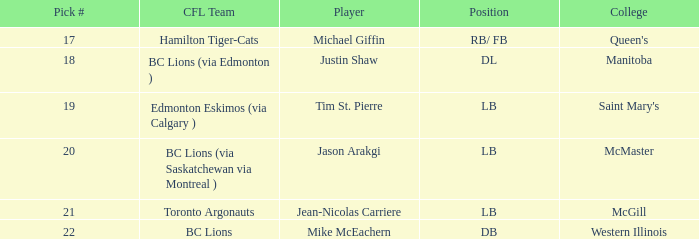For which college does jean-nicolas carriere participate in sports? McGill. Help me parse the entirety of this table. {'header': ['Pick #', 'CFL Team', 'Player', 'Position', 'College'], 'rows': [['17', 'Hamilton Tiger-Cats', 'Michael Giffin', 'RB/ FB', "Queen's"], ['18', 'BC Lions (via Edmonton )', 'Justin Shaw', 'DL', 'Manitoba'], ['19', 'Edmonton Eskimos (via Calgary )', 'Tim St. Pierre', 'LB', "Saint Mary's"], ['20', 'BC Lions (via Saskatchewan via Montreal )', 'Jason Arakgi', 'LB', 'McMaster'], ['21', 'Toronto Argonauts', 'Jean-Nicolas Carriere', 'LB', 'McGill'], ['22', 'BC Lions', 'Mike McEachern', 'DB', 'Western Illinois']]} 